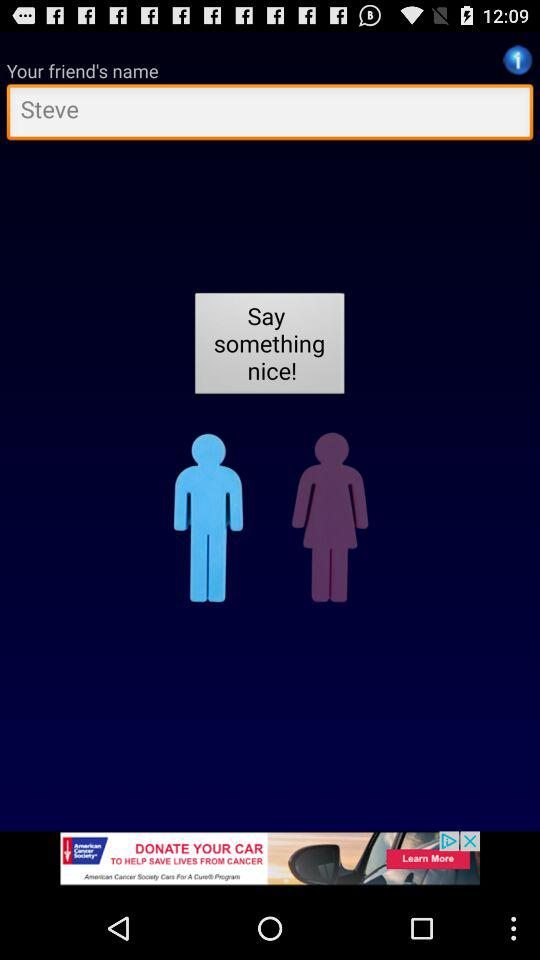What is the name of the friend? The name of the friend is Steve. 